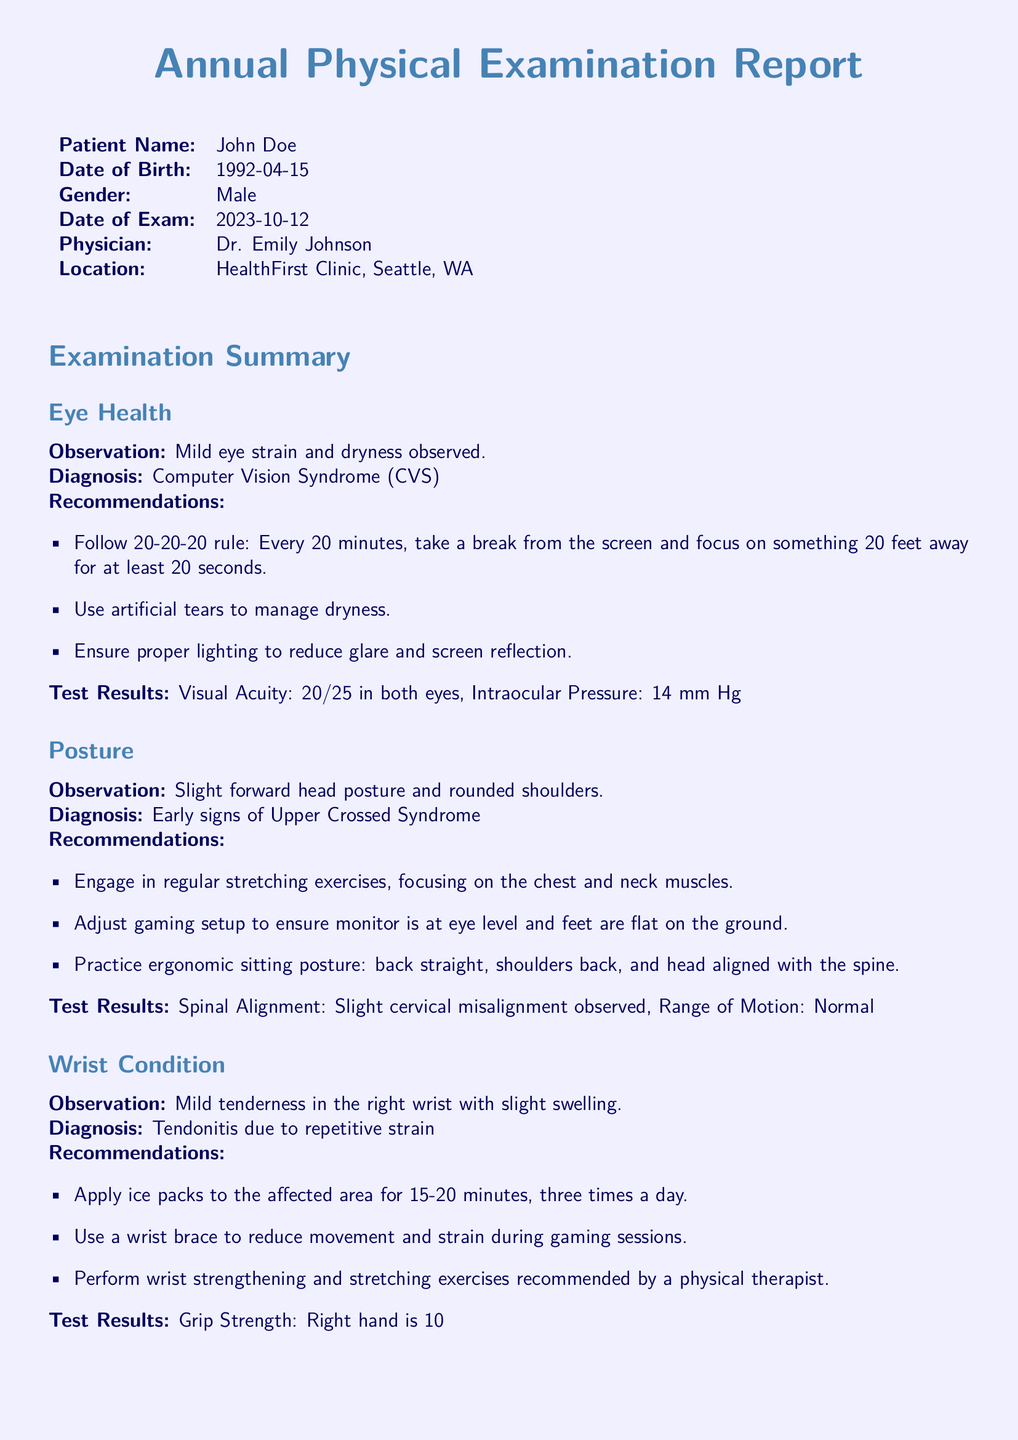What is the patient's name? The patient's name is clearly stated in the document under “Patient Name.”
Answer: John Doe What was the date of exam? The date of the exam is mentioned within the patient details section.
Answer: 2023-10-12 What is the diagnosis for eye health? The diagnosis for eye health is stated in the eye health observation section.
Answer: Computer Vision Syndrome (CVS) What should be done every 20 minutes according to the recommendations? This recommendation is part of the eye health section emphasizing the importance of breaks.
Answer: Follow 20-20-20 rule What type of condition was observed in the wrist? The condition observed in the wrist is detailed in the wrist condition section.
Answer: Tendonitis Which physician conducted the examination? The physician's name is listed in the introductory details of the document.
Answer: Dr. Emily Johnson What is the recommendation for gaming setup? This recommendation is found under the posture section and focuses on ergonomic arrangements.
Answer: Adjust gaming setup to ensure monitor is at eye level What is the planned next appointment date? The next appointment date is outlined in the follow-up section.
Answer: 2024-04-15 What is the grip strength difference between the hands? The report provides a comparative metric in the wrist condition findings.
Answer: 10% weaker 